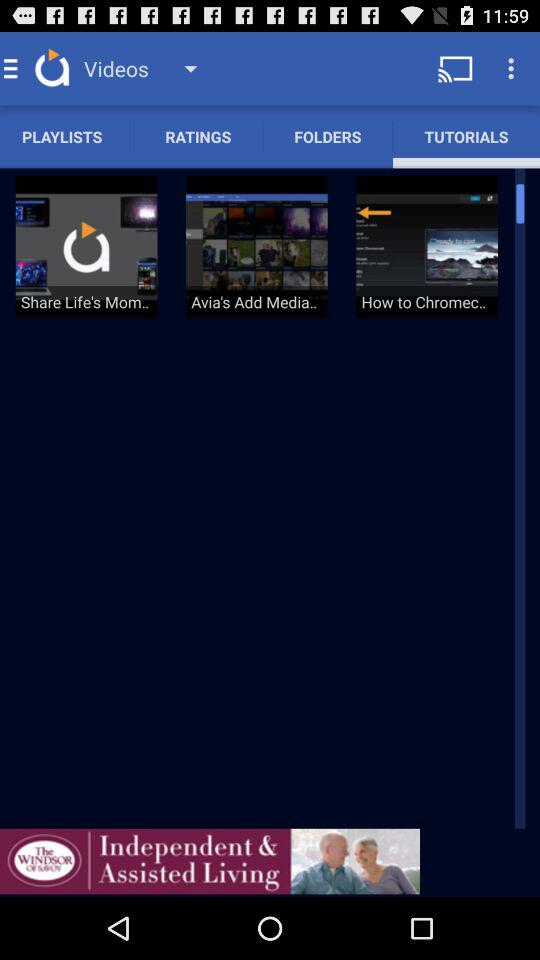Which tab am I on? You are on "TUTORIALS" tab. 